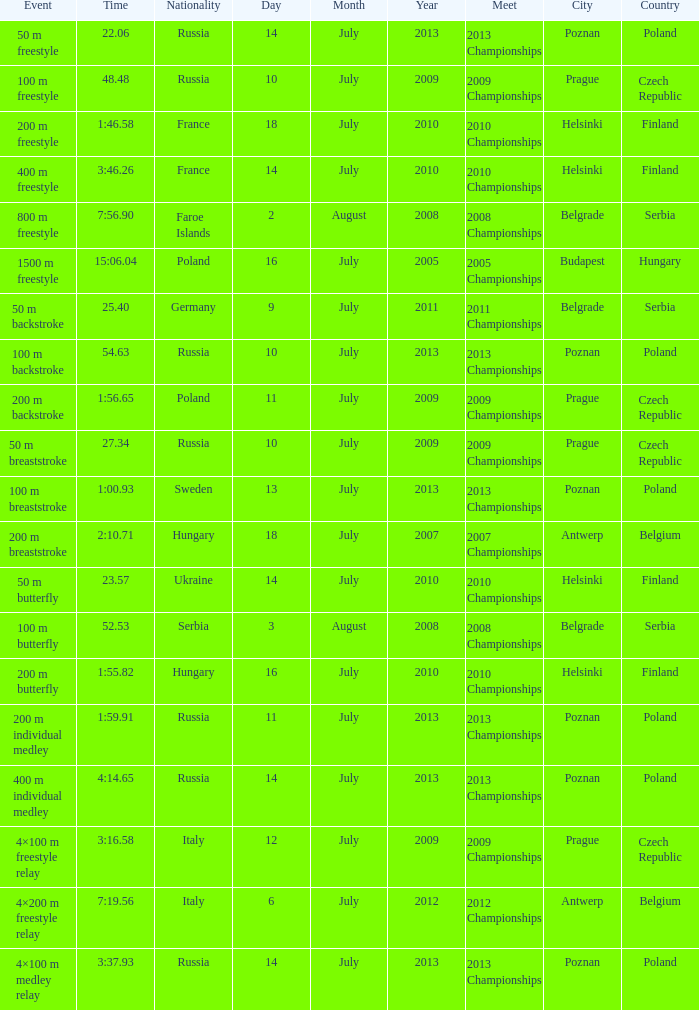Where were the 2008 championships with a time of 7:56.90 held? Belgrade , Serbia. 